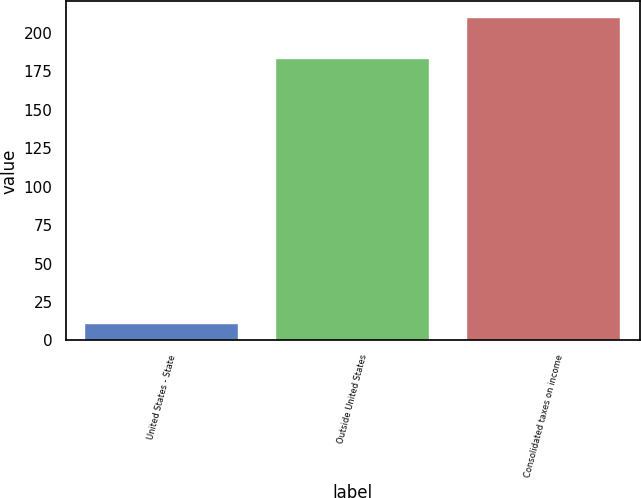Convert chart to OTSL. <chart><loc_0><loc_0><loc_500><loc_500><bar_chart><fcel>United States - State<fcel>Outside United States<fcel>Consolidated taxes on income<nl><fcel>11<fcel>183<fcel>210<nl></chart> 